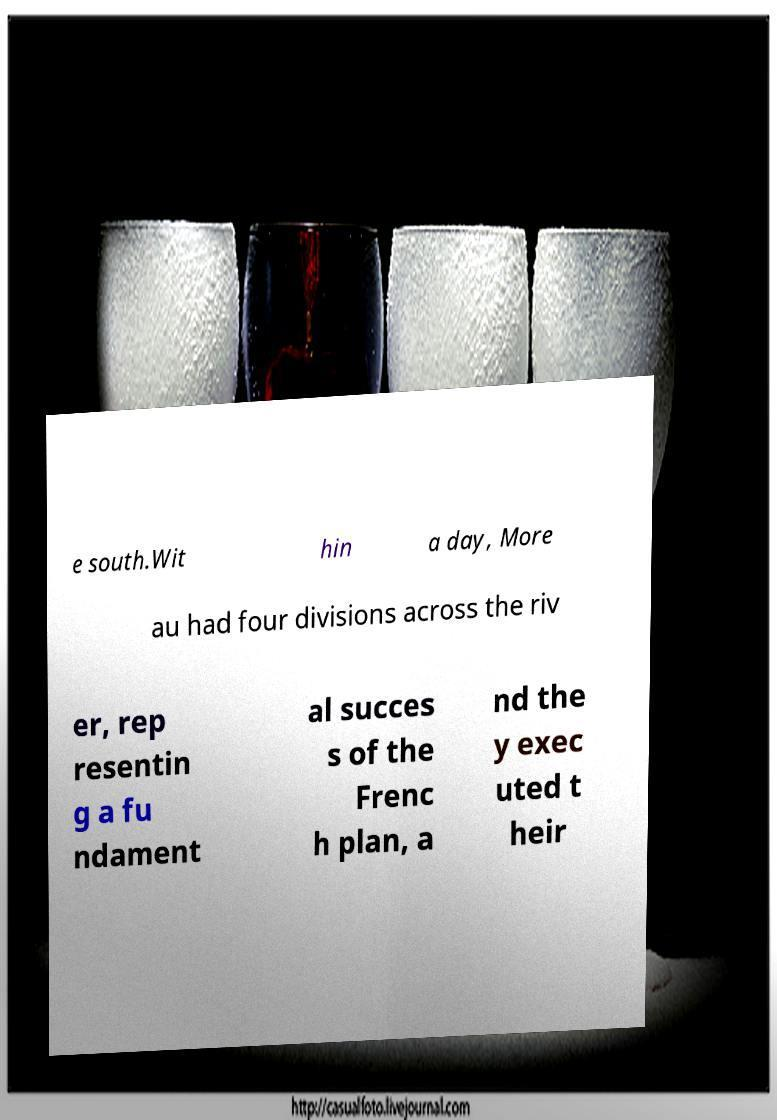Please identify and transcribe the text found in this image. e south.Wit hin a day, More au had four divisions across the riv er, rep resentin g a fu ndament al succes s of the Frenc h plan, a nd the y exec uted t heir 